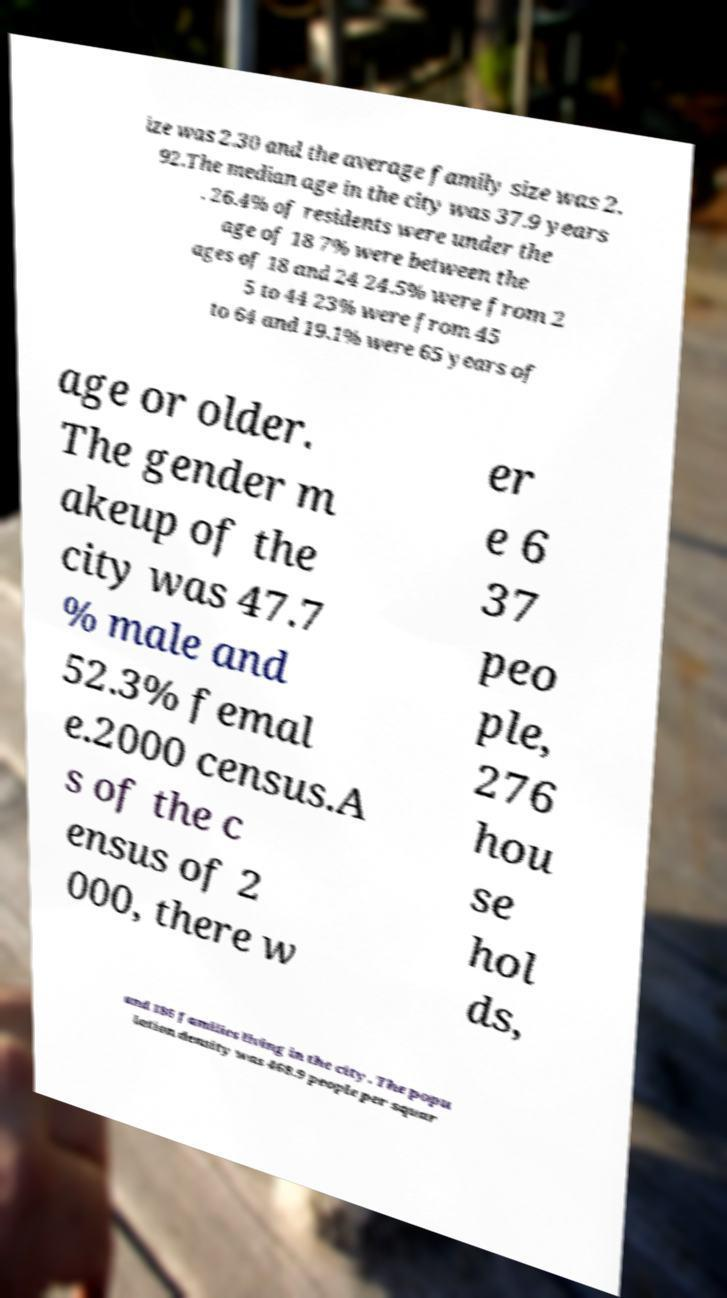For documentation purposes, I need the text within this image transcribed. Could you provide that? ize was 2.30 and the average family size was 2. 92.The median age in the city was 37.9 years . 26.4% of residents were under the age of 18 7% were between the ages of 18 and 24 24.5% were from 2 5 to 44 23% were from 45 to 64 and 19.1% were 65 years of age or older. The gender m akeup of the city was 47.7 % male and 52.3% femal e.2000 census.A s of the c ensus of 2 000, there w er e 6 37 peo ple, 276 hou se hol ds, and 186 families living in the city. The popu lation density was 468.9 people per squar 